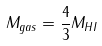Convert formula to latex. <formula><loc_0><loc_0><loc_500><loc_500>M _ { g a s } = \frac { 4 } { 3 } M _ { H I }</formula> 